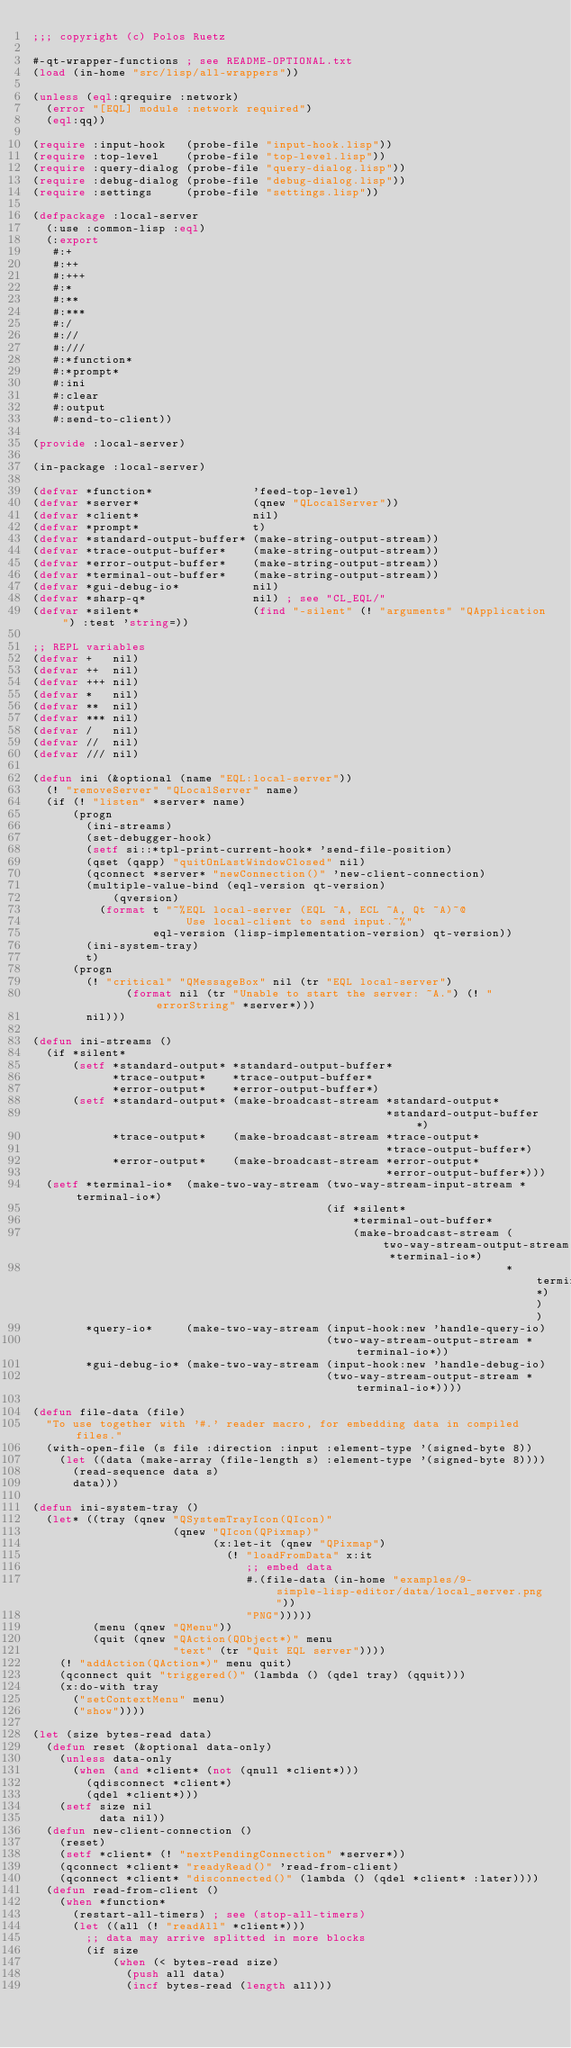Convert code to text. <code><loc_0><loc_0><loc_500><loc_500><_Lisp_>;;; copyright (c) Polos Ruetz

#-qt-wrapper-functions ; see README-OPTIONAL.txt
(load (in-home "src/lisp/all-wrappers"))

(unless (eql:qrequire :network)
  (error "[EQL] module :network required")
  (eql:qq))

(require :input-hook   (probe-file "input-hook.lisp"))
(require :top-level    (probe-file "top-level.lisp"))
(require :query-dialog (probe-file "query-dialog.lisp"))
(require :debug-dialog (probe-file "debug-dialog.lisp"))
(require :settings     (probe-file "settings.lisp"))

(defpackage :local-server
  (:use :common-lisp :eql)
  (:export
   #:+
   #:++
   #:+++
   #:*
   #:**
   #:***
   #:/
   #://
   #:///
   #:*function*
   #:*prompt*
   #:ini
   #:clear
   #:output
   #:send-to-client))

(provide :local-server)

(in-package :local-server)

(defvar *function*               'feed-top-level)
(defvar *server*                 (qnew "QLocalServer"))
(defvar *client*                 nil)
(defvar *prompt*                 t)
(defvar *standard-output-buffer* (make-string-output-stream))
(defvar *trace-output-buffer*    (make-string-output-stream))
(defvar *error-output-buffer*    (make-string-output-stream))
(defvar *terminal-out-buffer*    (make-string-output-stream))
(defvar *gui-debug-io*           nil)
(defvar *sharp-q*                nil) ; see "CL_EQL/"
(defvar *silent*                 (find "-silent" (! "arguments" "QApplication") :test 'string=))

;; REPL variables
(defvar +   nil)
(defvar ++  nil)
(defvar +++ nil)
(defvar *   nil)
(defvar **  nil)
(defvar *** nil)
(defvar /   nil)
(defvar //  nil)
(defvar /// nil)

(defun ini (&optional (name "EQL:local-server"))
  (! "removeServer" "QLocalServer" name)
  (if (! "listen" *server* name)
      (progn
        (ini-streams)
        (set-debugger-hook)
        (setf si::*tpl-print-current-hook* 'send-file-position)
        (qset (qapp) "quitOnLastWindowClosed" nil)
        (qconnect *server* "newConnection()" 'new-client-connection)
        (multiple-value-bind (eql-version qt-version)
            (qversion)
          (format t "~%EQL local-server (EQL ~A, ECL ~A, Qt ~A)~@
                       Use local-client to send input.~%"
                  eql-version (lisp-implementation-version) qt-version))
        (ini-system-tray)
        t)
      (progn
        (! "critical" "QMessageBox" nil (tr "EQL local-server")
              (format nil (tr "Unable to start the server: ~A.") (! "errorString" *server*)))
        nil)))

(defun ini-streams ()
  (if *silent*
      (setf *standard-output* *standard-output-buffer*
            *trace-output*    *trace-output-buffer*
            *error-output*    *error-output-buffer*)
      (setf *standard-output* (make-broadcast-stream *standard-output*
                                                     *standard-output-buffer*)
            *trace-output*    (make-broadcast-stream *trace-output*
                                                     *trace-output-buffer*)
            *error-output*    (make-broadcast-stream *error-output*
                                                     *error-output-buffer*)))
  (setf *terminal-io*  (make-two-way-stream (two-way-stream-input-stream *terminal-io*)
                                            (if *silent*
                                                *terminal-out-buffer*
                                                (make-broadcast-stream (two-way-stream-output-stream *terminal-io*)
                                                                       *terminal-out-buffer*)))
        *query-io*     (make-two-way-stream (input-hook:new 'handle-query-io)
                                            (two-way-stream-output-stream *terminal-io*))
        *gui-debug-io* (make-two-way-stream (input-hook:new 'handle-debug-io)
                                            (two-way-stream-output-stream *terminal-io*))))

(defun file-data (file)
  "To use together with '#.' reader macro, for embedding data in compiled files."
  (with-open-file (s file :direction :input :element-type '(signed-byte 8))
    (let ((data (make-array (file-length s) :element-type '(signed-byte 8))))
      (read-sequence data s)
      data)))

(defun ini-system-tray ()
  (let* ((tray (qnew "QSystemTrayIcon(QIcon)"
                     (qnew "QIcon(QPixmap)"
                           (x:let-it (qnew "QPixmap")
                             (! "loadFromData" x:it
                                ;; embed data
                                #.(file-data (in-home "examples/9-simple-lisp-editor/data/local_server.png"))
                                "PNG")))))
         (menu (qnew "QMenu"))
         (quit (qnew "QAction(QObject*)" menu
                     "text" (tr "Quit EQL server"))))
    (! "addAction(QAction*)" menu quit)
    (qconnect quit "triggered()" (lambda () (qdel tray) (qquit)))
    (x:do-with tray
      ("setContextMenu" menu)
      ("show"))))

(let (size bytes-read data)
  (defun reset (&optional data-only)
    (unless data-only
      (when (and *client* (not (qnull *client*)))
        (qdisconnect *client*)
        (qdel *client*)))
    (setf size nil
          data nil))
  (defun new-client-connection ()
    (reset)
    (setf *client* (! "nextPendingConnection" *server*))
    (qconnect *client* "readyRead()" 'read-from-client)
    (qconnect *client* "disconnected()" (lambda () (qdel *client* :later))))
  (defun read-from-client ()
    (when *function*
      (restart-all-timers) ; see (stop-all-timers)
      (let ((all (! "readAll" *client*)))
        ;; data may arrive splitted in more blocks
        (if size
            (when (< bytes-read size)
              (push all data)
              (incf bytes-read (length all)))</code> 